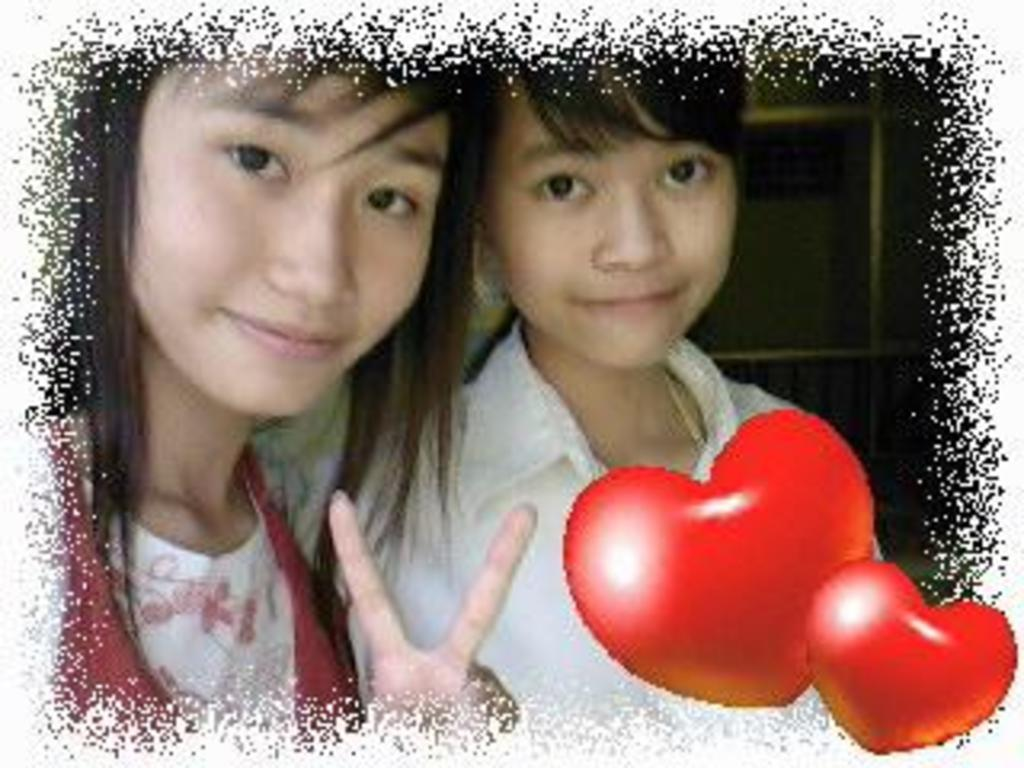How many people are in the image? There are two women in the image. Can you describe any additional features or elements in the image? There is a watermark in the bottom right of the image. What type of flowers are being held by the women in the image? There are no flowers visible in the image; it only features two women and a watermark. 